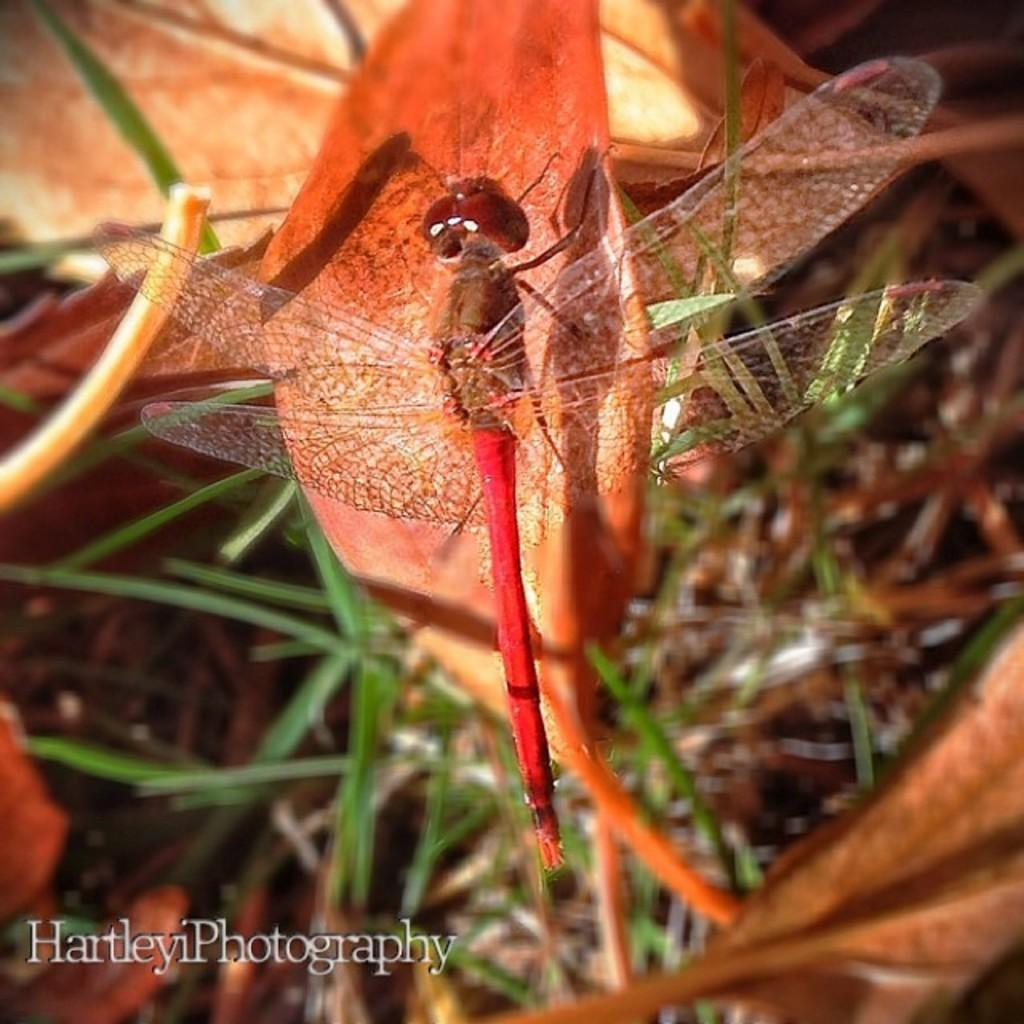What insect is present in the image? There is a dragonfly in the image. What is the dragonfly doing in the image? The dragonfly is laying on a leaf. How is the background of the image depicted? The background of the leaf is blurred. What type of cheese is visible on the dragonfly's wing in the image? There is no cheese present in the image; it features a dragonfly laying on a leaf. 